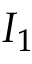Convert formula to latex. <formula><loc_0><loc_0><loc_500><loc_500>I _ { 1 }</formula> 